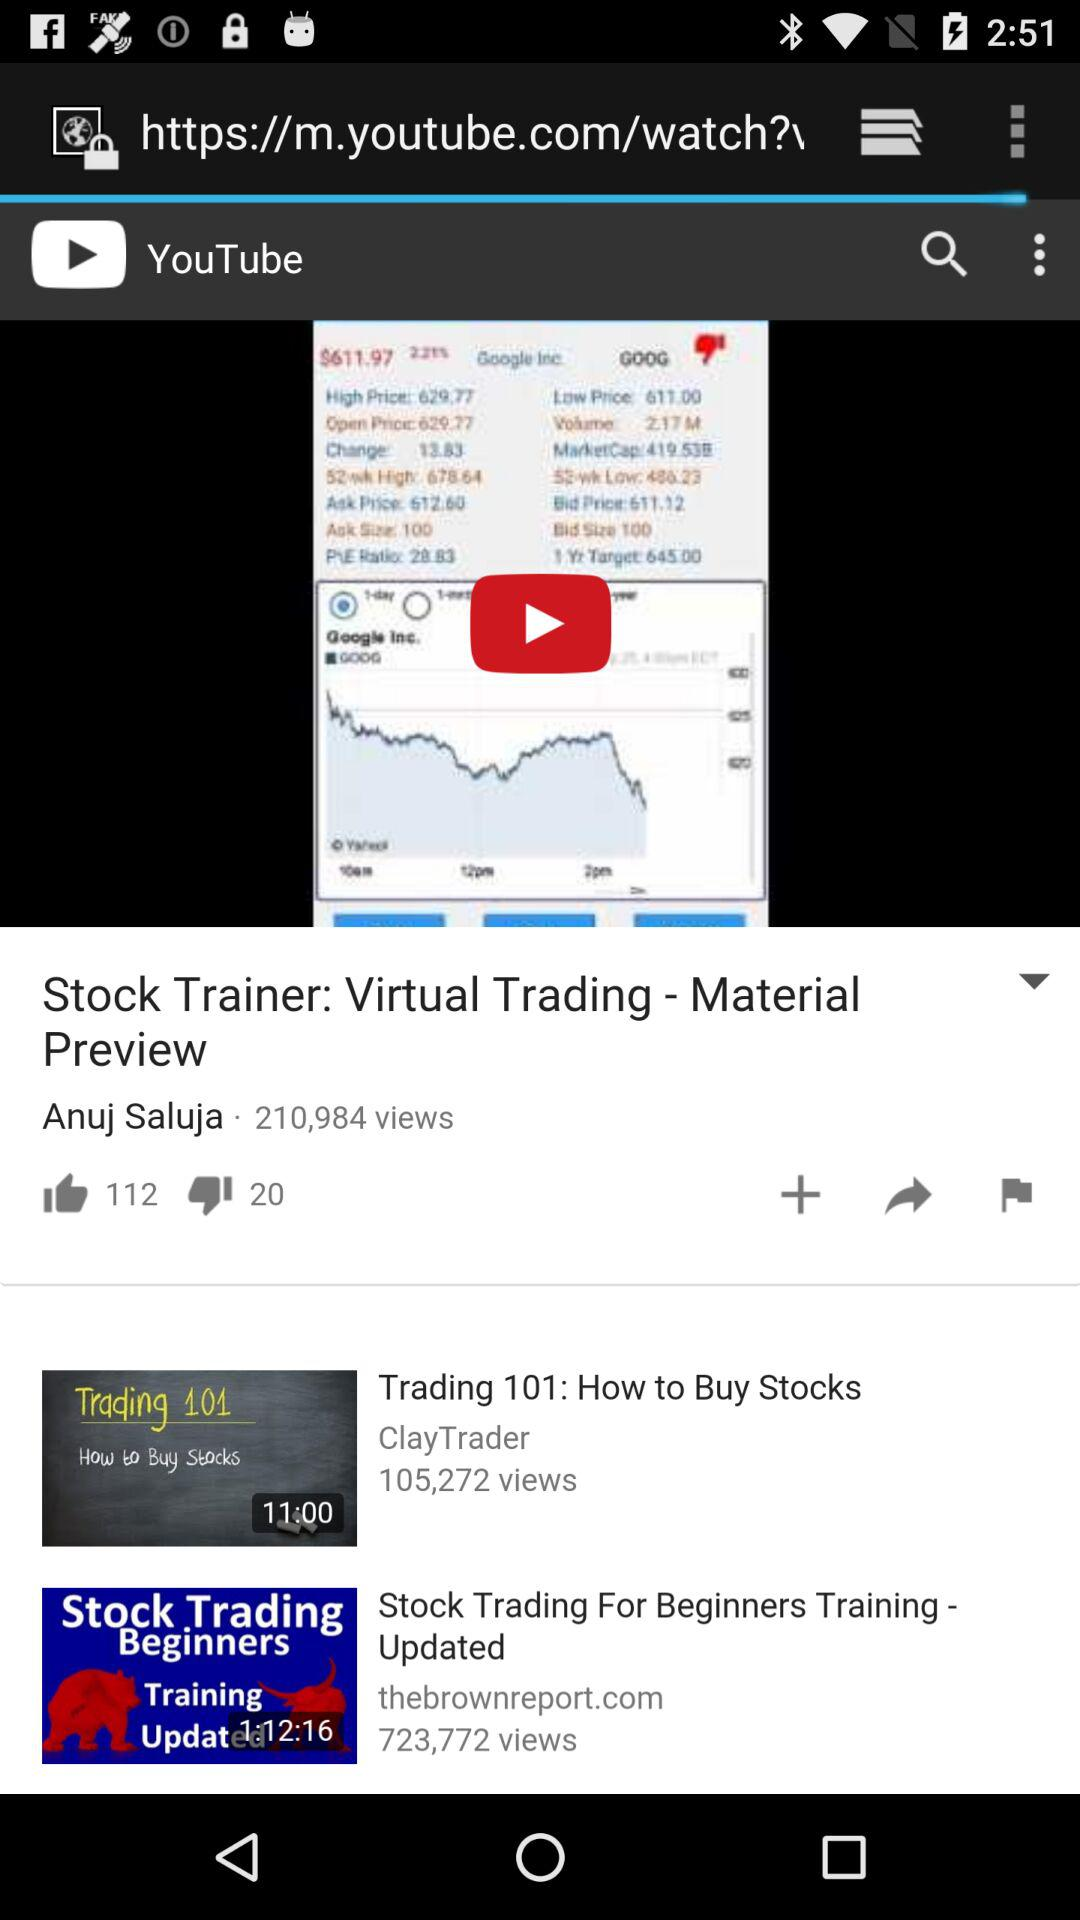What is the duration of "Trading 101: How to Buy Stocks"? The duration is 11 minutes. 